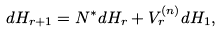<formula> <loc_0><loc_0><loc_500><loc_500>d H _ { r + 1 } = N ^ { \ast } d H _ { r } + V _ { r } ^ { ( n ) } d H _ { 1 } ,</formula> 